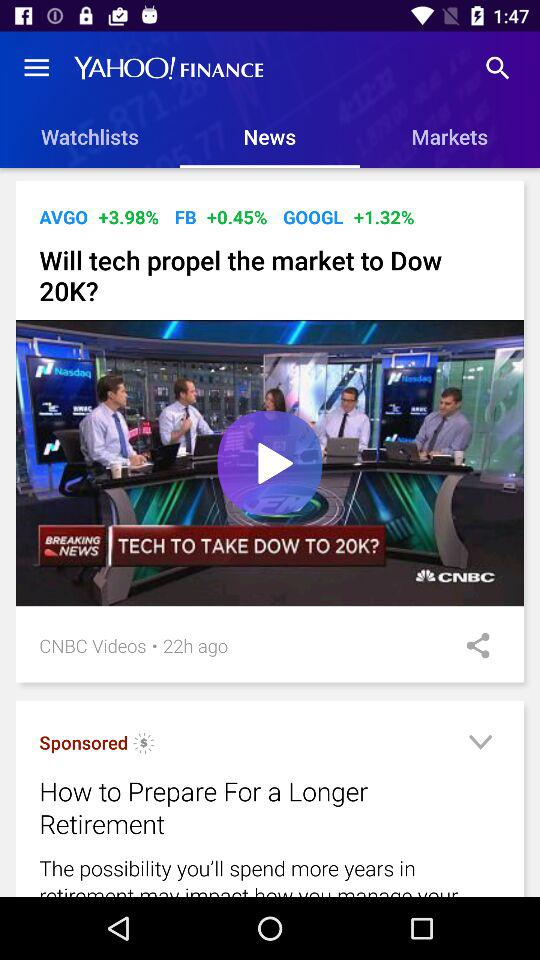What is the selected tab? The selected tab is "News". 